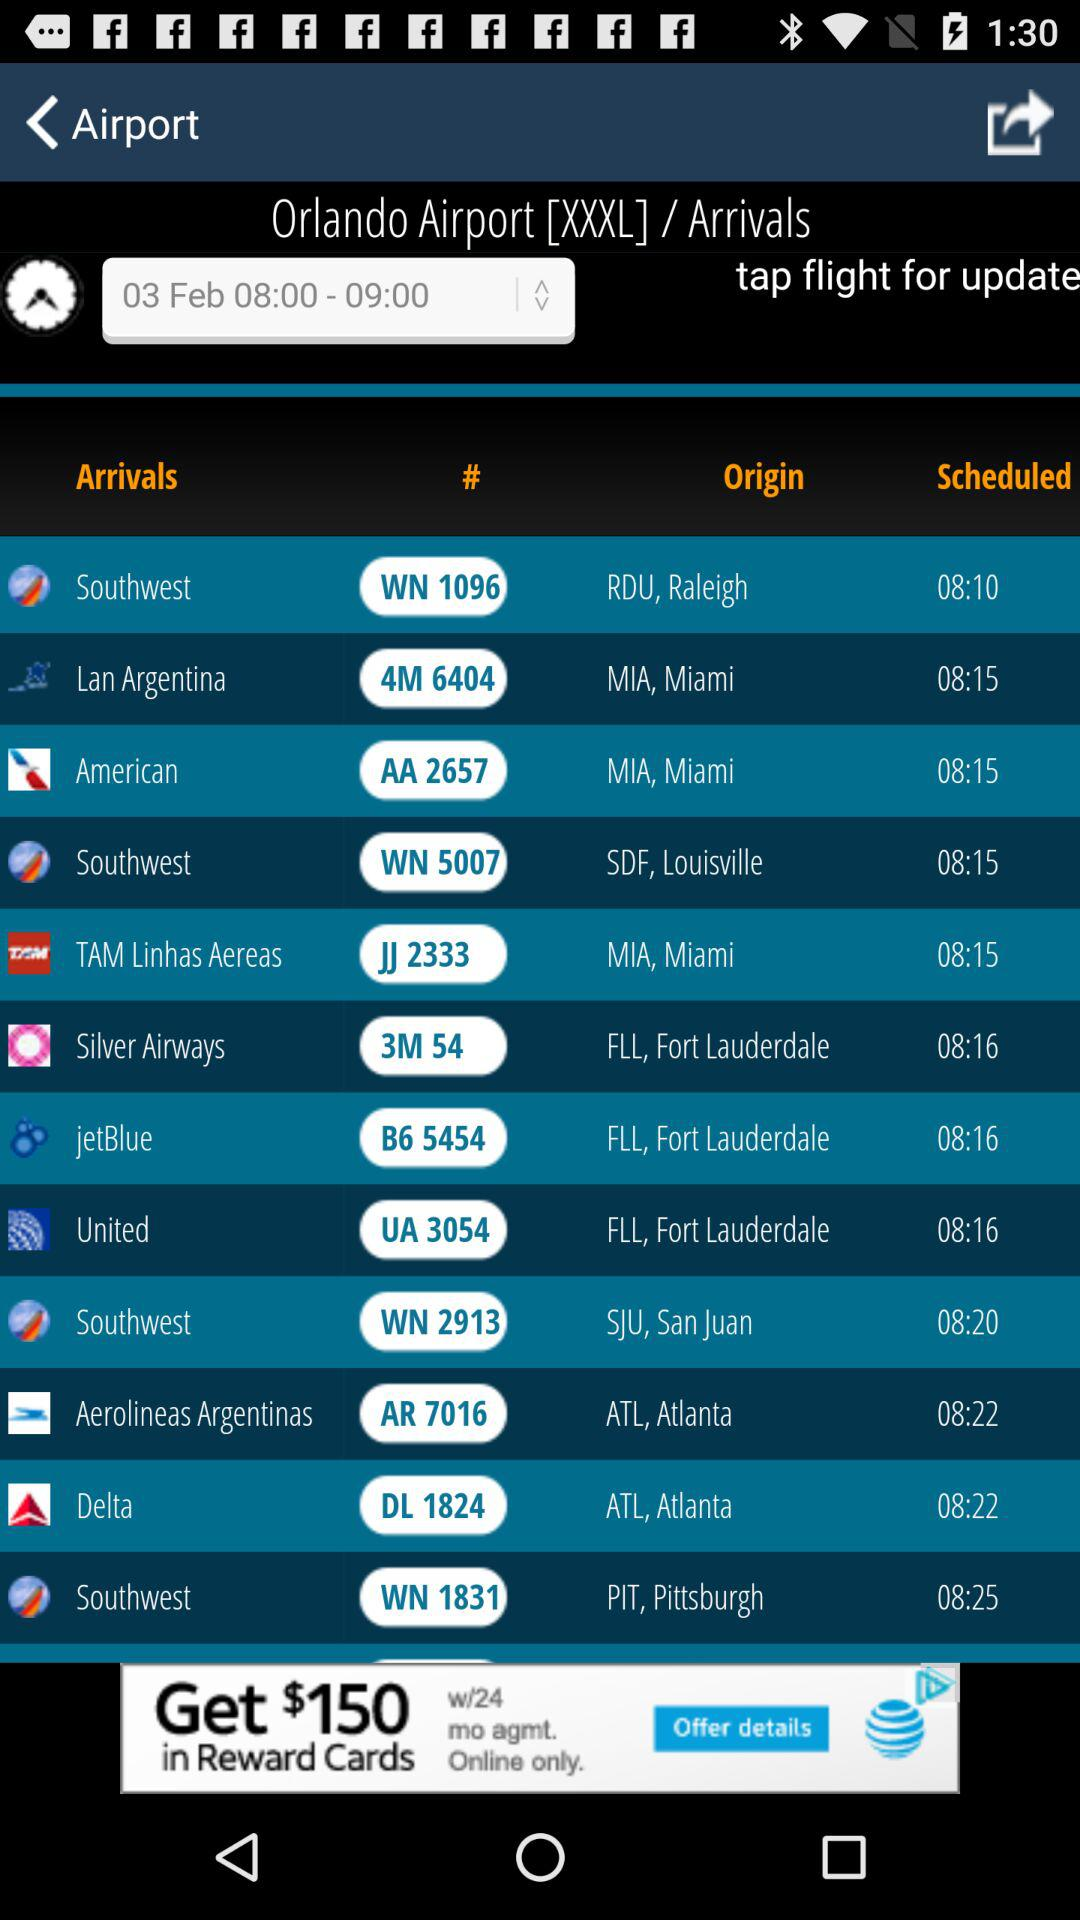What is the ID of Delta flight? The ID is "DL 1824". 